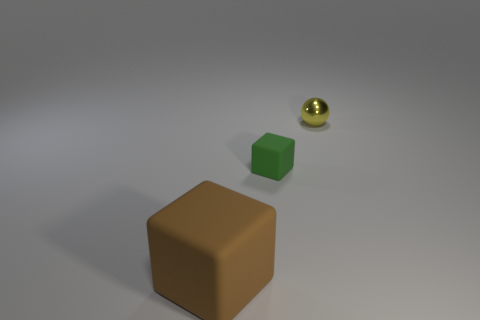There is a small metallic ball that is behind the matte thing that is on the left side of the tiny object in front of the sphere; what is its color?
Ensure brevity in your answer.  Yellow. Are the large thing and the tiny yellow thing made of the same material?
Make the answer very short. No. Is the brown rubber object the same shape as the green matte object?
Offer a very short reply. Yes. Are there the same number of tiny green rubber objects on the right side of the tiny yellow metallic object and small yellow shiny objects left of the small green rubber block?
Provide a short and direct response. Yes. What color is the other cube that is made of the same material as the green block?
Provide a succinct answer. Brown. How many tiny yellow things have the same material as the green cube?
Keep it short and to the point. 0. Does the tiny thing that is in front of the tiny yellow shiny object have the same color as the big thing?
Offer a terse response. No. What number of yellow shiny objects are the same shape as the brown rubber thing?
Ensure brevity in your answer.  0. Are there an equal number of brown blocks that are behind the small yellow object and tiny green rubber cubes?
Your answer should be compact. No. The metal ball that is the same size as the green block is what color?
Keep it short and to the point. Yellow. 